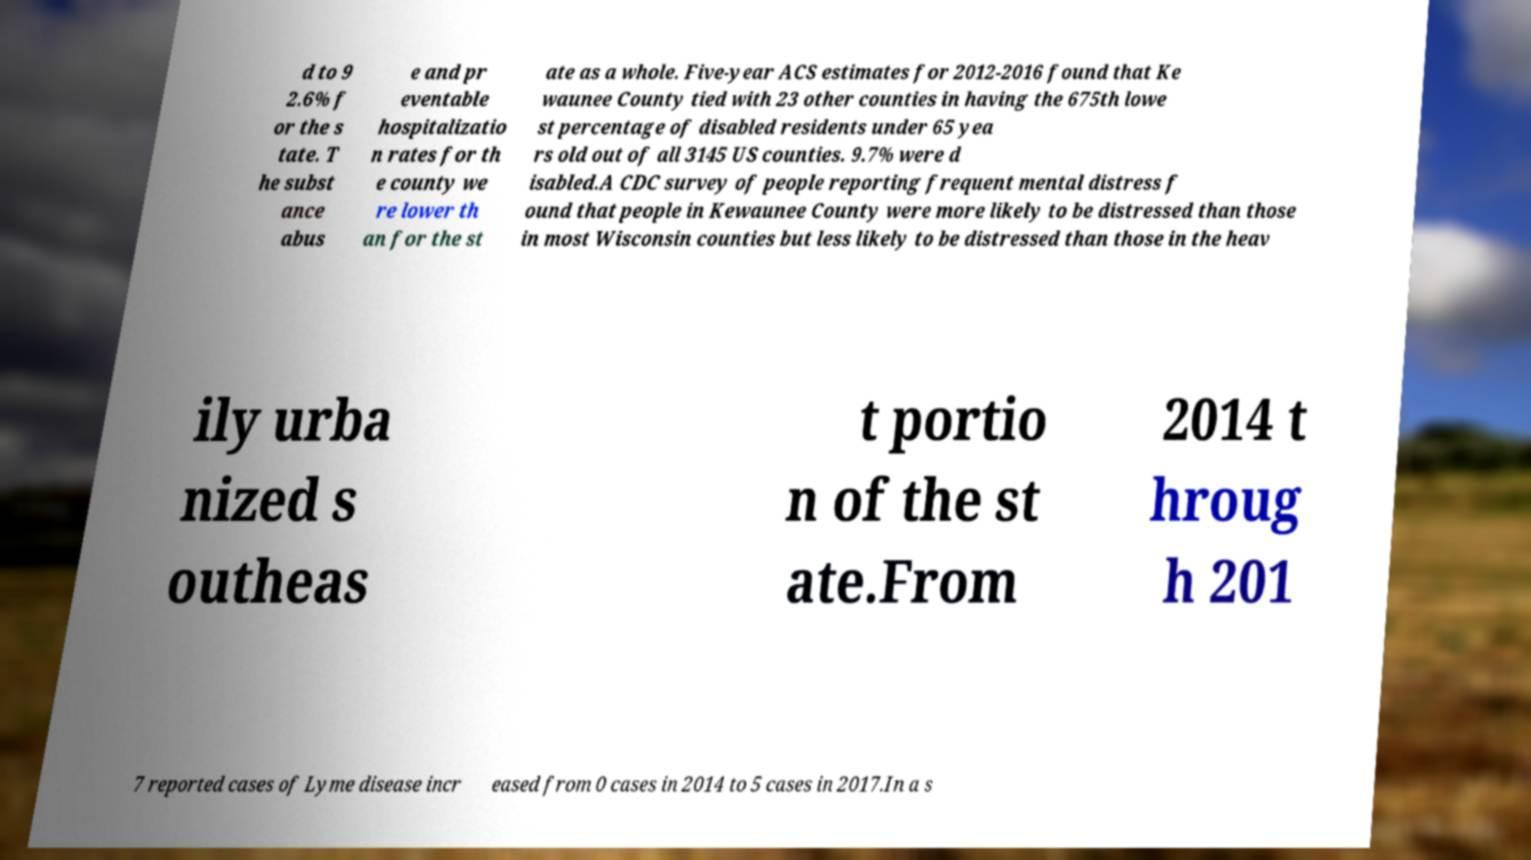I need the written content from this picture converted into text. Can you do that? d to 9 2.6% f or the s tate. T he subst ance abus e and pr eventable hospitalizatio n rates for th e county we re lower th an for the st ate as a whole. Five-year ACS estimates for 2012-2016 found that Ke waunee County tied with 23 other counties in having the 675th lowe st percentage of disabled residents under 65 yea rs old out of all 3145 US counties. 9.7% were d isabled.A CDC survey of people reporting frequent mental distress f ound that people in Kewaunee County were more likely to be distressed than those in most Wisconsin counties but less likely to be distressed than those in the heav ily urba nized s outheas t portio n of the st ate.From 2014 t hroug h 201 7 reported cases of Lyme disease incr eased from 0 cases in 2014 to 5 cases in 2017.In a s 